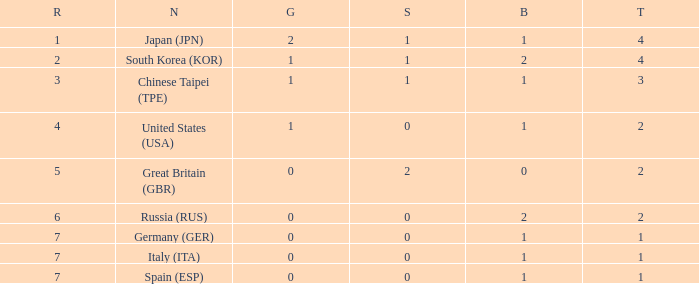What is the smallest number of gold of a country of rank 6, with 2 bronzes? None. 